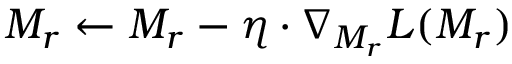Convert formula to latex. <formula><loc_0><loc_0><loc_500><loc_500>M _ { r } \leftarrow M _ { r } - \eta \cdot \nabla _ { M _ { r } } L ( M _ { r } )</formula> 